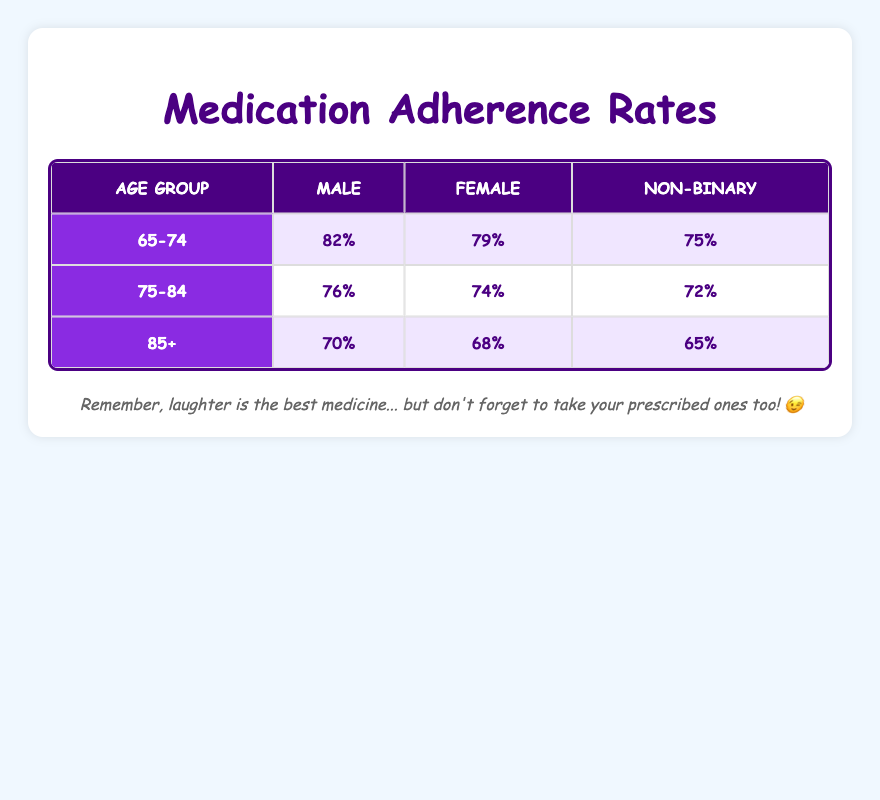What is the adherence rate for females in the 65-74 age group? According to the table, the adherence rate for females in the 65-74 age group is listed as 79%.
Answer: 79% Which gender has the highest adherence rate in the 75-84 age group? The table shows that males have an adherence rate of 76%, while females have 74%. Therefore, males have the highest adherence rate in this age group.
Answer: Male What is the difference in adherence rates between males and females in the 85+ age group? For males, the adherence rate is 70%, and for females, it is 68%. The difference is calculated by subtracting the female rate from the male rate: 70% - 68% = 2%.
Answer: 2% Is the adherence rate for non-binary individuals in the 75-84 age group greater than those in the 85+ age group? The adherence rate for non-binary individuals in the 75-84 age group is 72%, and in the 85+ age group, it is 65%. Since 72% is greater than 65%, the statement is true.
Answer: Yes What is the average adherence rate for all genders in the 65-74 age group? The adherence rates in the 65-74 age group are 82% (male), 79% (female), and 75% (non-binary). To find the average, sum these rates: 82 + 79 + 75 = 236, then divide by 3 (number of groups): 236 / 3 = 78.67%.
Answer: 78.67% Which age group has the lowest overall adherence rate regardless of gender? The lowest adherence rates in each age group are 70% for males, 68% for females, and 65% for non-binary individuals in the 85+ age group. Since 65% is the lowest of these rates, the 85+ age group has the lowest overall adherence rate.
Answer: 85+ Are females more adherent than non-binary individuals in the 75-84 age group? The adherence rate for females in the 75-84 age group is 74%, while for non-binary individuals it is 72%. Since 74% is greater than 72%, the statement is true.
Answer: Yes What is the total adherence rate for all genders in the 65-74 age group? The adherence rates for all genders in the 65-74 age group are 82% (male), 79% (female), and 75% (non-binary). To get the total adherence rate, we sum these rates: 82 + 79 + 75 = 236%.
Answer: 236% 